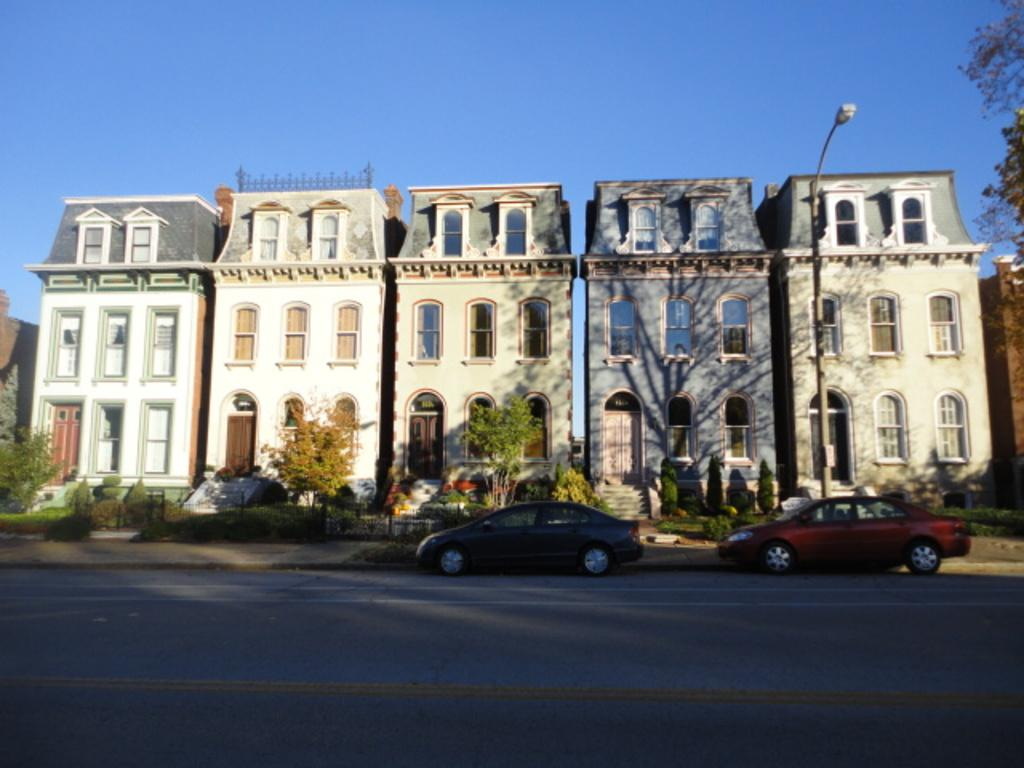How many cars are parked on the road in the image? There are two cars parked on the road in the image. What can be seen behind the cars? There are plants behind the cars. What is located behind the plants? There are buildings behind the plants. Can you identify any street furniture in the image? Yes, there is a lamp post in the image. What type of glue is being used to hold the shock in the stomach of the car in the image? There is no mention of a shock or stomach in the image; it features two cars parked on the road with plants, buildings, and a lamp post visible. 